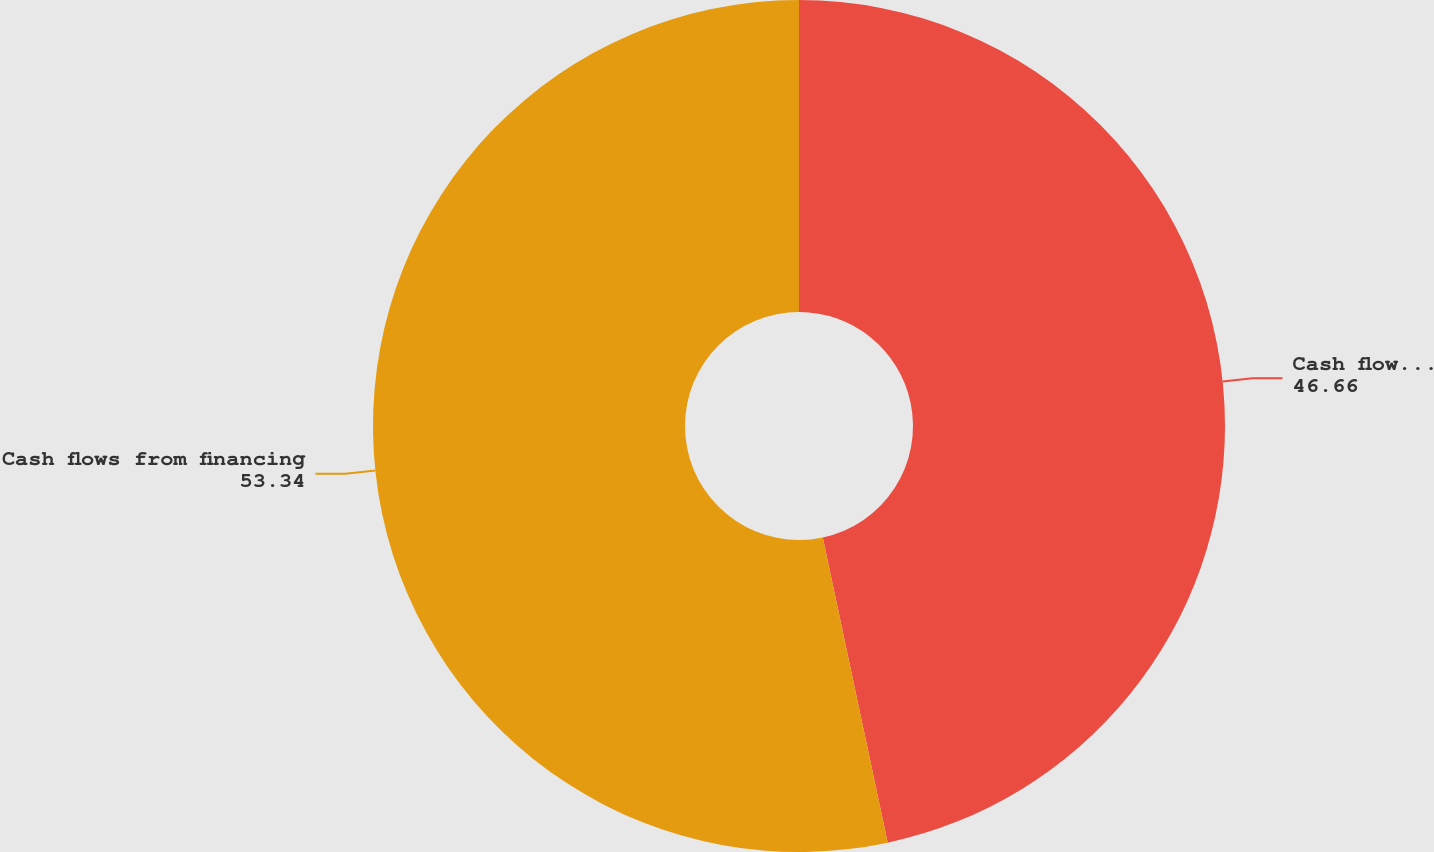Convert chart. <chart><loc_0><loc_0><loc_500><loc_500><pie_chart><fcel>Cash flows from operating<fcel>Cash flows from financing<nl><fcel>46.66%<fcel>53.34%<nl></chart> 